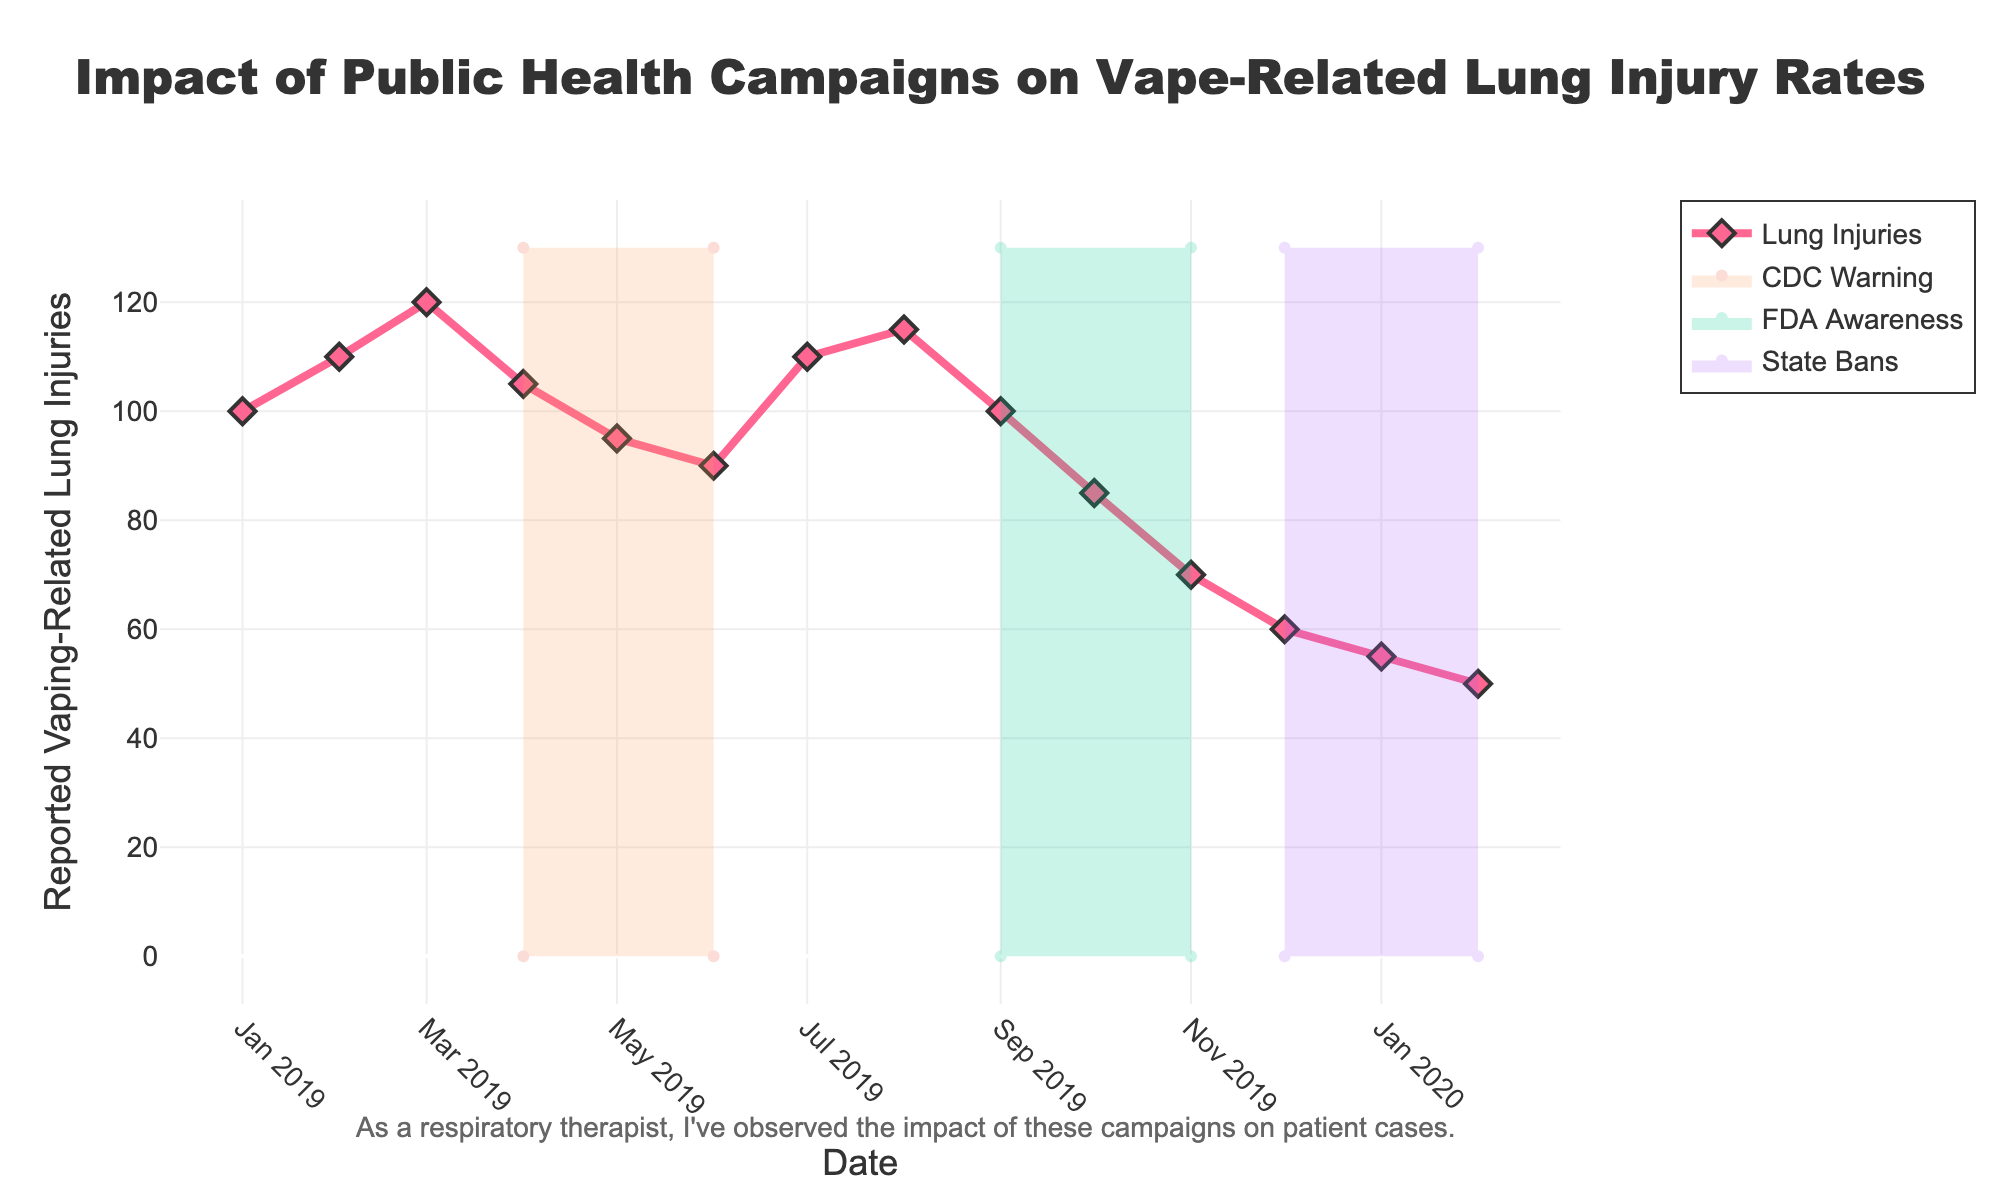What's the title of the figure? The title is written prominently at the top of the figure. It reads "Impact of Public Health Campaigns on Vape-Related Lung Injury Rates".
Answer: Impact of Public Health Campaigns on Vape-Related Lung Injury Rates How many public health campaigns are represented in the figure? The figure shows four distinct periods with color shading, indicating different campaigns.
Answer: Four When did the "CDC Warning" campaign start? The "CDC Warning" label appears starting from April 2019.
Answer: April 2019 What was the number of reported vaping-related lung injuries at the peak before any campaigns? By looking at the early part of the time series before any campaigns, the peak is at March 2019 with 120 injuries.
Answer: 120 During which campaign do we observe the steepest decline in reported vaping-related lung injuries? By comparing the slopes of the lines during different campaigns, the steepest decline is during "FDA Awareness" from 100 in September 2019 to 70 in November 2019.
Answer: FDA Awareness Compare the number of reported injuries at the start and end of the "State Bans" campaign. The "State Bans" campaign starts in December 2019 with 60 injuries and ends in February 2020 with 50 injuries. The difference is 10.
Answer: 60 and 50 How did the number of reported injuries change during the "None" periods? During the "None" periods before and between campaigns, the number of injuries generally fluctuates, starting at 100 in January 2019, peaking at 120 in March 2019, dropping slightly, then rising again to 115 in August 2019.
Answer: Fluctuating Which month had the highest number of reported vaping-related lung injuries? The highest point on the graph occurs in March 2019 with 120 reported injuries.
Answer: March 2019 How long did the "FDA Awareness" campaign last? By looking at the shaded area for "FDA Awareness," it spans from September 2019 to November 2019, which is three months.
Answer: Three months Compare the effectiveness of "CDC Warning" and "State Bans" campaigns in reducing the number of injuries. Both campaigns initially start with a certain number of injuries. "CDC Warning" starts at 105 injuries and drops to 90 injuries at the end (a reduction of 15), while "State Bans" starts at 60 injuries and drops to 50 injuries (a reduction of 10).
Answer: CDC Warning more effective 